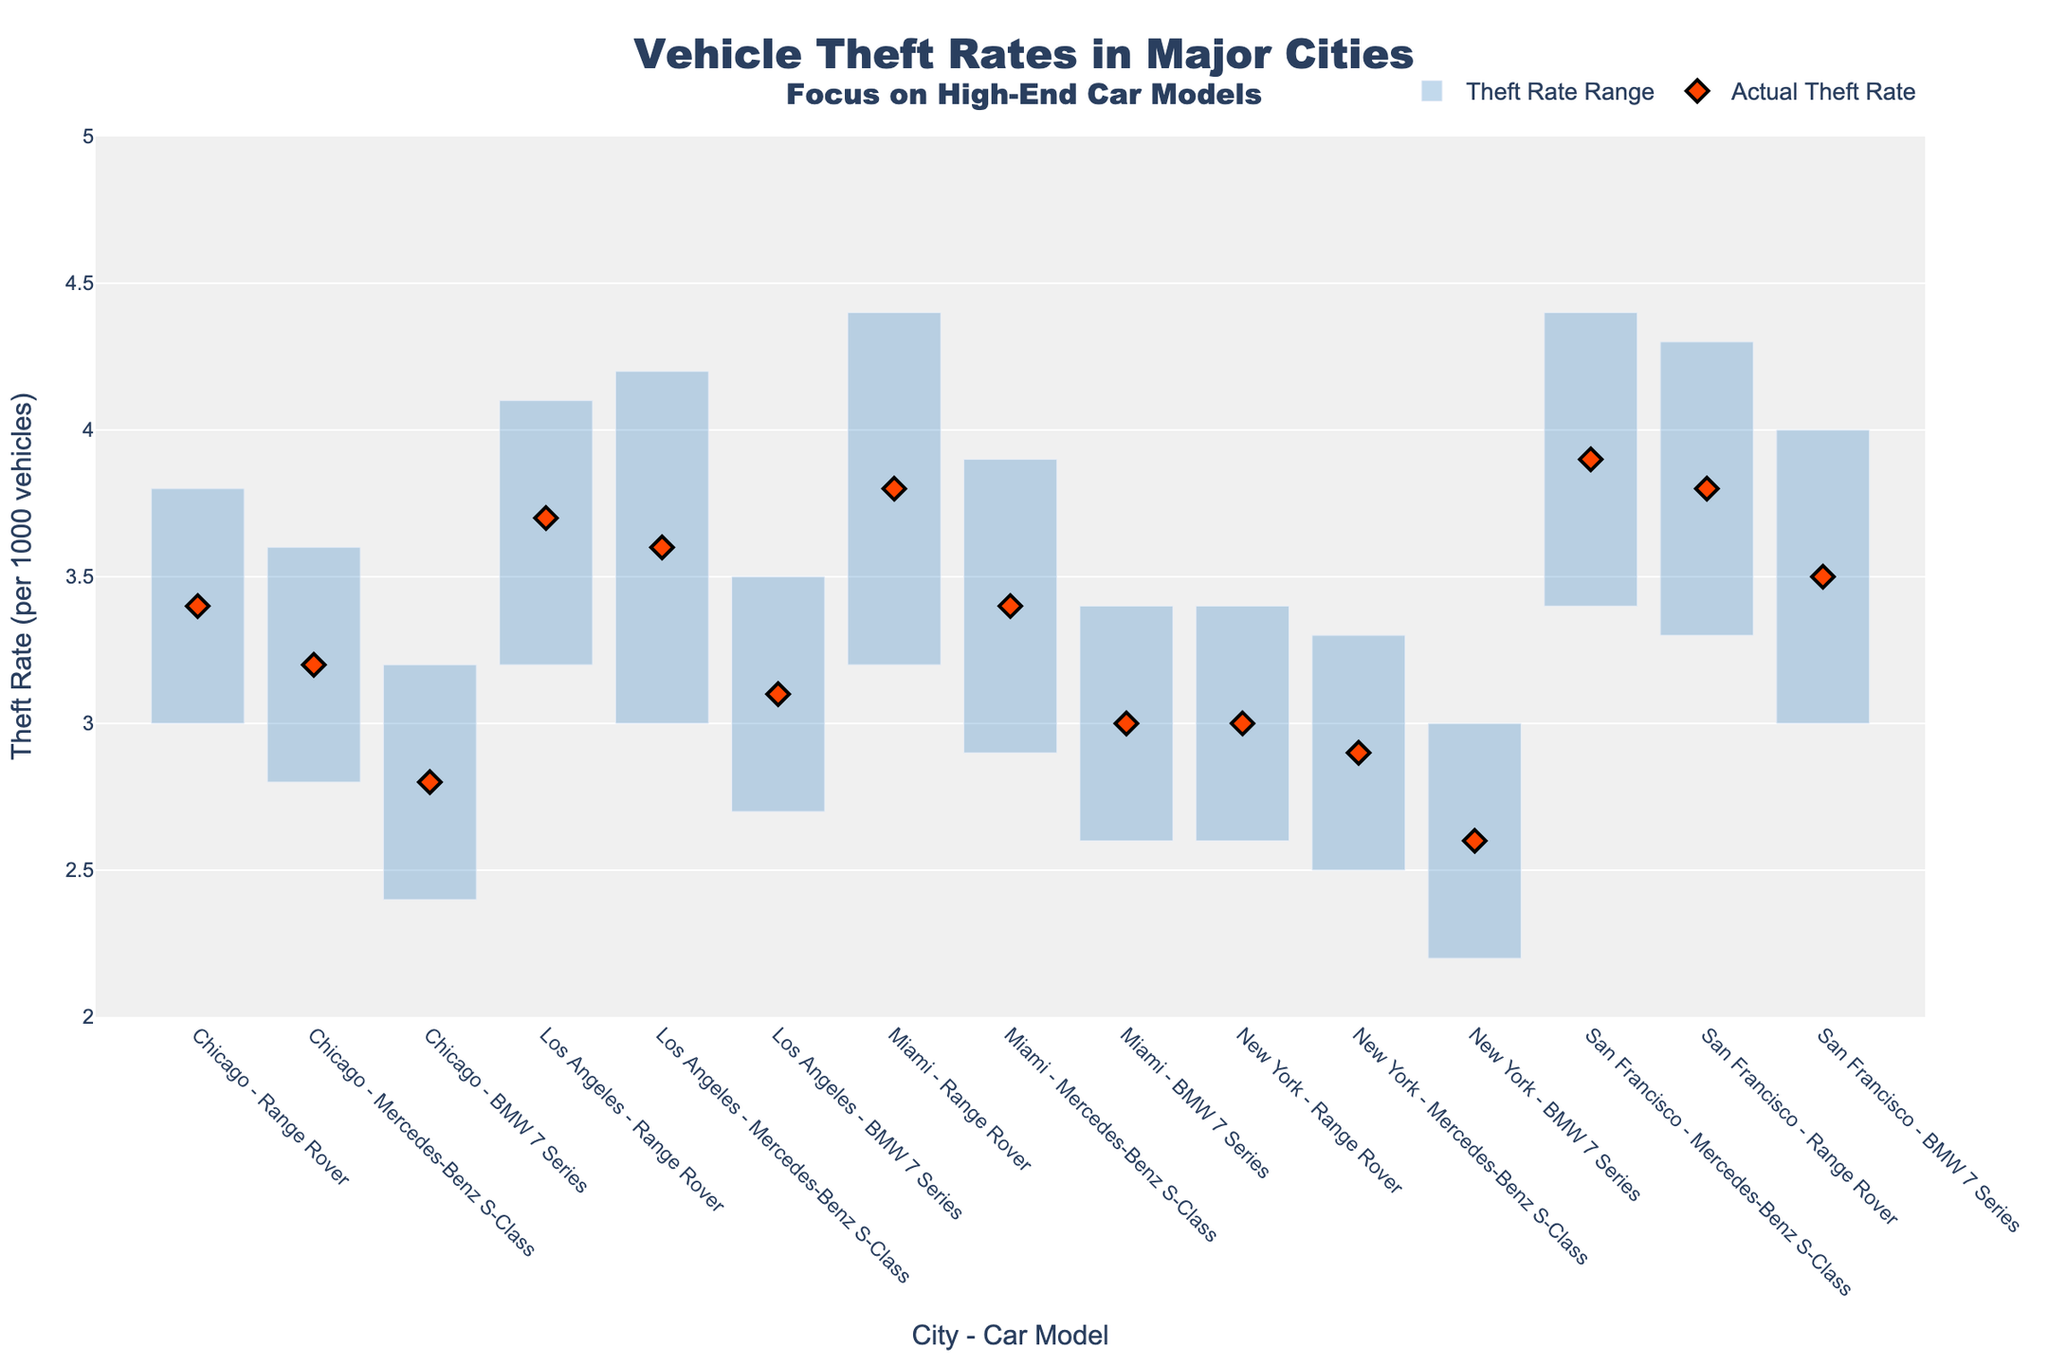Which city has the highest average theft rate for Mercedes-Benz S-Class? To find the highest average theft rate for Mercedes-Benz S-Class, we locate the bar for each city in the plot and see the average theft rate in each city. San Francisco has the highest theft rate for the Mercedes-Benz S-Class at 3.9.
Answer: San Francisco What is the difference in maximum theft rate for Range Rover between Los Angeles and Miami? Identify the maximum theft rate for Range Rover in Los Angeles and Miami from the plot. The maximum theft rate for Los Angeles is 4.1 and for Miami is 4.4. Subtract these to find the difference: 4.4 - 4.1.
Answer: 0.3 Which high-end car model has the lowest minimum theft rate in Chicago? Look at the plot portion for Chicago and identify the minimum theft rates for each car model. The BMW 7 Series has a minimum theft rate of 2.4, which is the lowest among the given models.
Answer: BMW 7 Series What is the range of theft rates for Mercedes-Benz S-Class in New York? Check the New York section for the minimum and maximum range for Mercedes-Benz S-Class. The minimum is 2.5 and the maximum is 3.3. The range is calculated as 3.3 - 2.5.
Answer: 0.8 Which city has the smallest range of theft rates across all car models? Compare the range bars for each car model in the cities. The city with the smallest combined range is New York. The ranges are 0.8 for Mercedes-Benz S-Class, 0.8 for BMW 7 Series, and 0.8 for Range Rover.
Answer: New York What is the average actual theft rate of high-end car models in San Francisco? Identify the actual theft rates of all three car models in San Francisco from the plot, which are 3.9 (Mercedes-Benz S-Class), 3.5 (BMW 7 Series), and 3.8 (Range Rover). Calculate the average as follows: (3.9 + 3.5 + 3.8) / 3.
Answer: 3.73 Which car model shows the least variation in theft rate in Los Angeles? Find the difference between the maximum and minimum theft rates for each car model in Los Angeles. Mercedes-Benz S-Class (0.4), BMW 7 Series (0.8), Range Rover (0.9). The Mercedes-Benz S-Class shows the least variation.
Answer: Mercedes-Benz S-Class In which city does the Range Rover have the widest range of theft rates? Compare the range (maximum minus minimum) for Range Rover in all the cities. Miami has the widest range of 1.2 (4.4 - 3.2).
Answer: Miami 